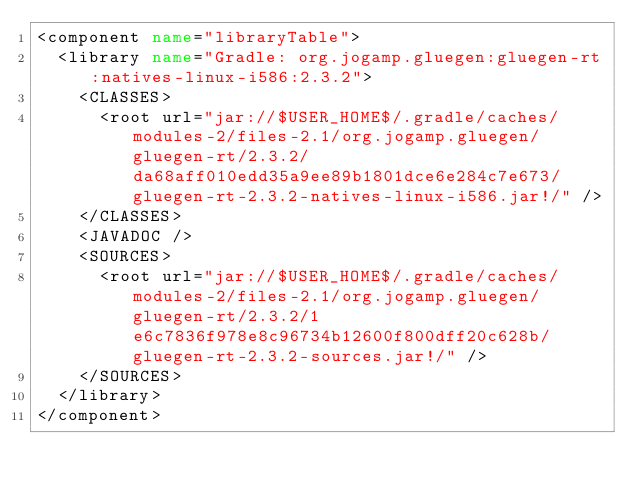Convert code to text. <code><loc_0><loc_0><loc_500><loc_500><_XML_><component name="libraryTable">
  <library name="Gradle: org.jogamp.gluegen:gluegen-rt:natives-linux-i586:2.3.2">
    <CLASSES>
      <root url="jar://$USER_HOME$/.gradle/caches/modules-2/files-2.1/org.jogamp.gluegen/gluegen-rt/2.3.2/da68aff010edd35a9ee89b1801dce6e284c7e673/gluegen-rt-2.3.2-natives-linux-i586.jar!/" />
    </CLASSES>
    <JAVADOC />
    <SOURCES>
      <root url="jar://$USER_HOME$/.gradle/caches/modules-2/files-2.1/org.jogamp.gluegen/gluegen-rt/2.3.2/1e6c7836f978e8c96734b12600f800dff20c628b/gluegen-rt-2.3.2-sources.jar!/" />
    </SOURCES>
  </library>
</component></code> 